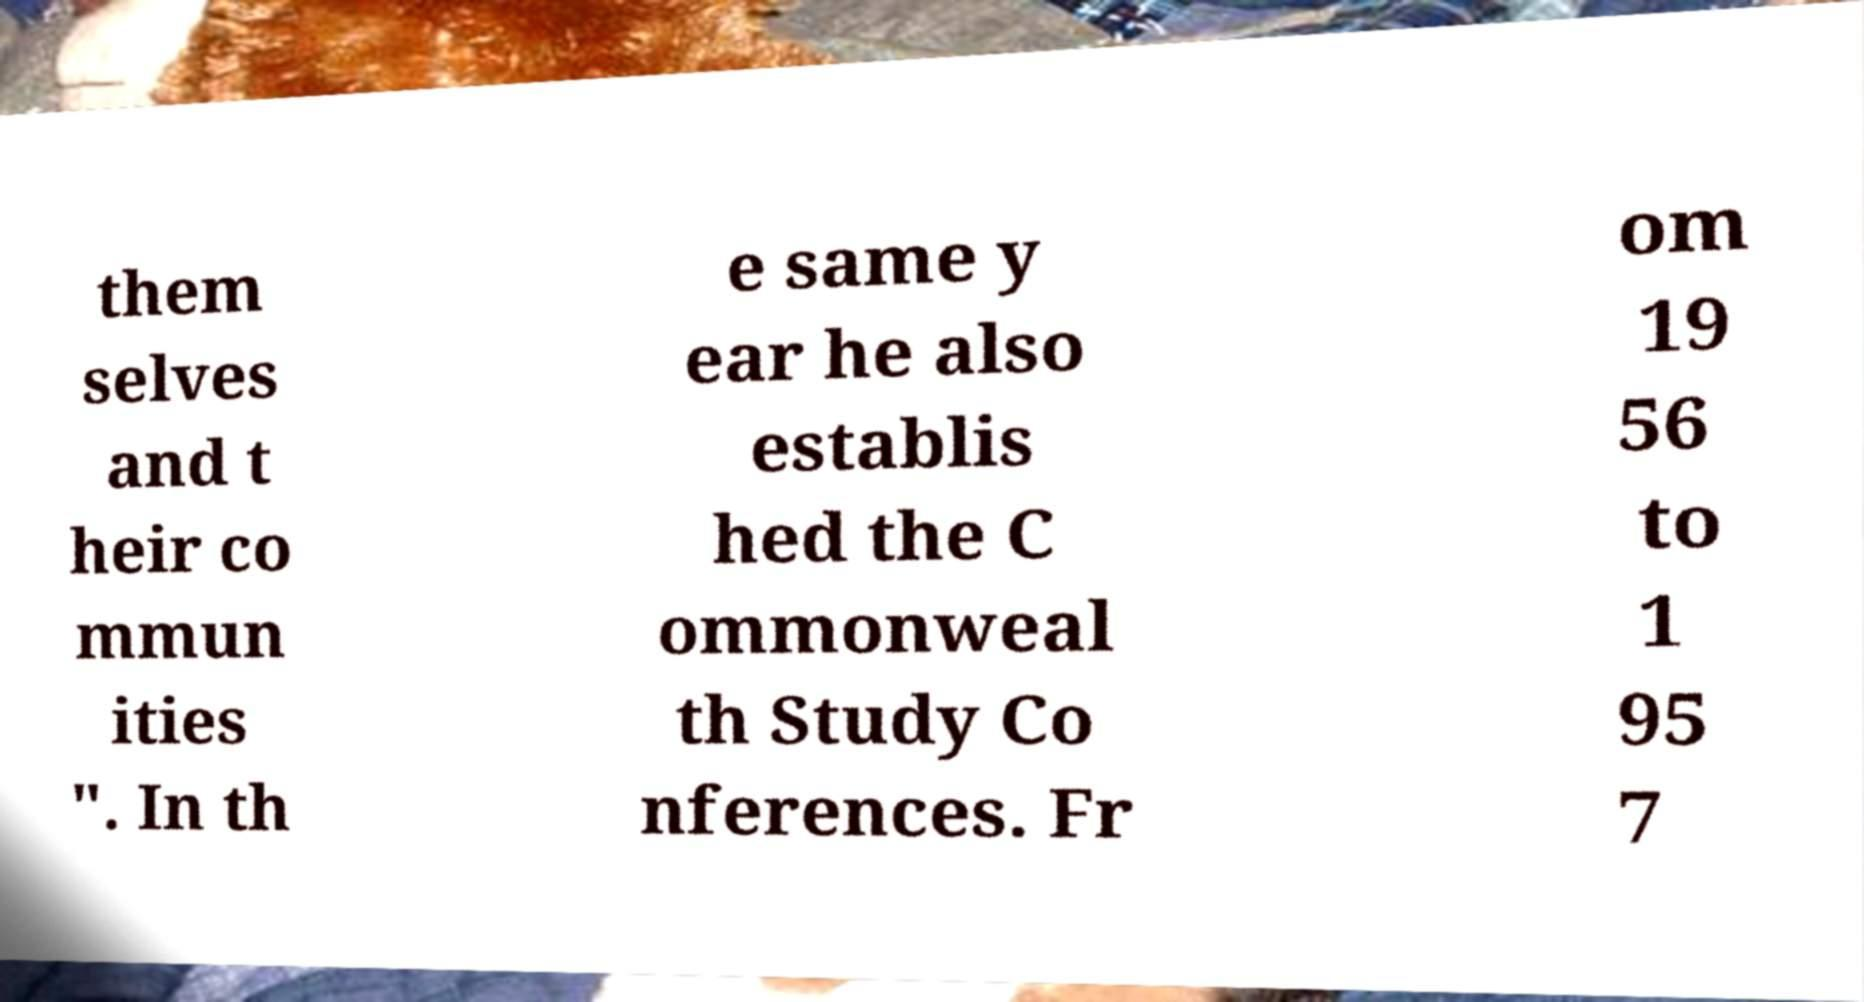Please identify and transcribe the text found in this image. them selves and t heir co mmun ities ". In th e same y ear he also establis hed the C ommonweal th Study Co nferences. Fr om 19 56 to 1 95 7 